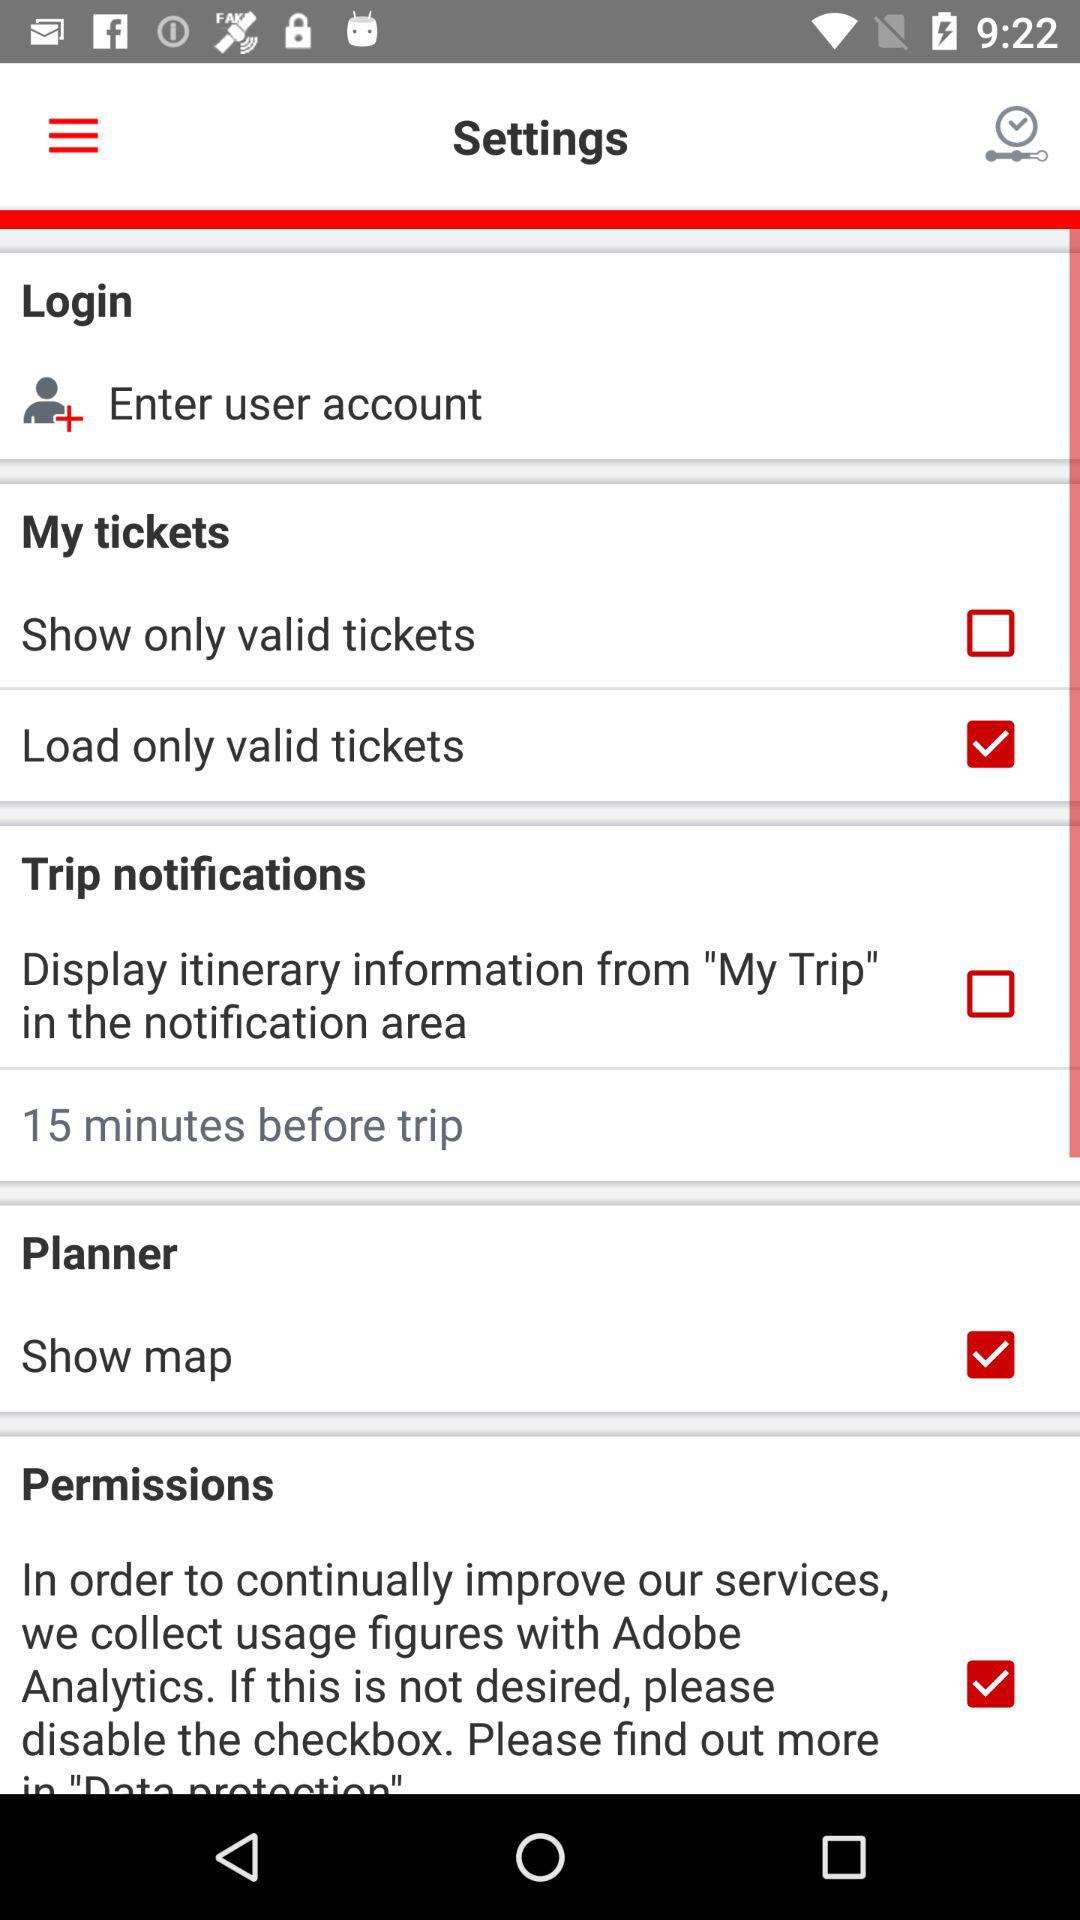What is the status of the "Load only valid tickets"? The status of the "Load only valid tickets" is "on". 